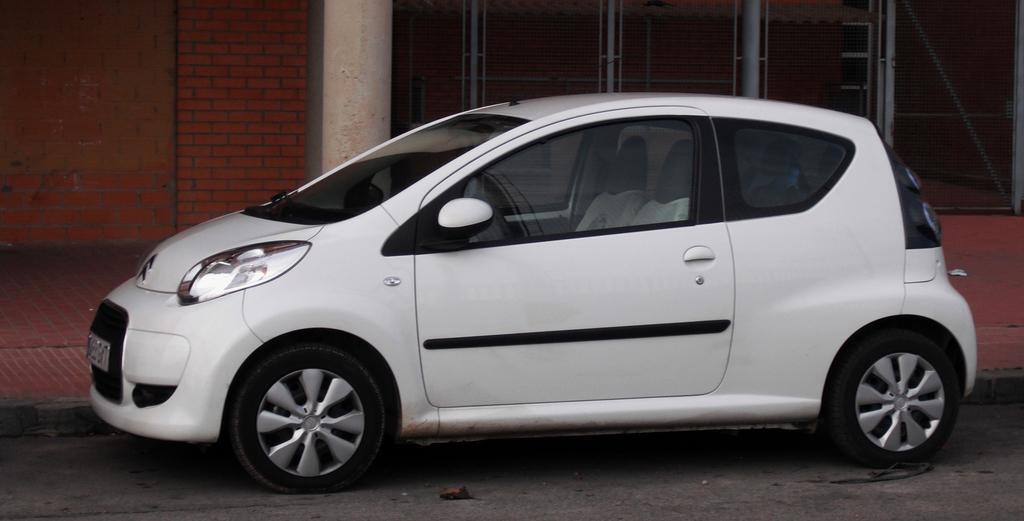Can you describe this image briefly? In this image we can see a white color car on the road. In the background, we can see the pillars, brick wall and the fence. 